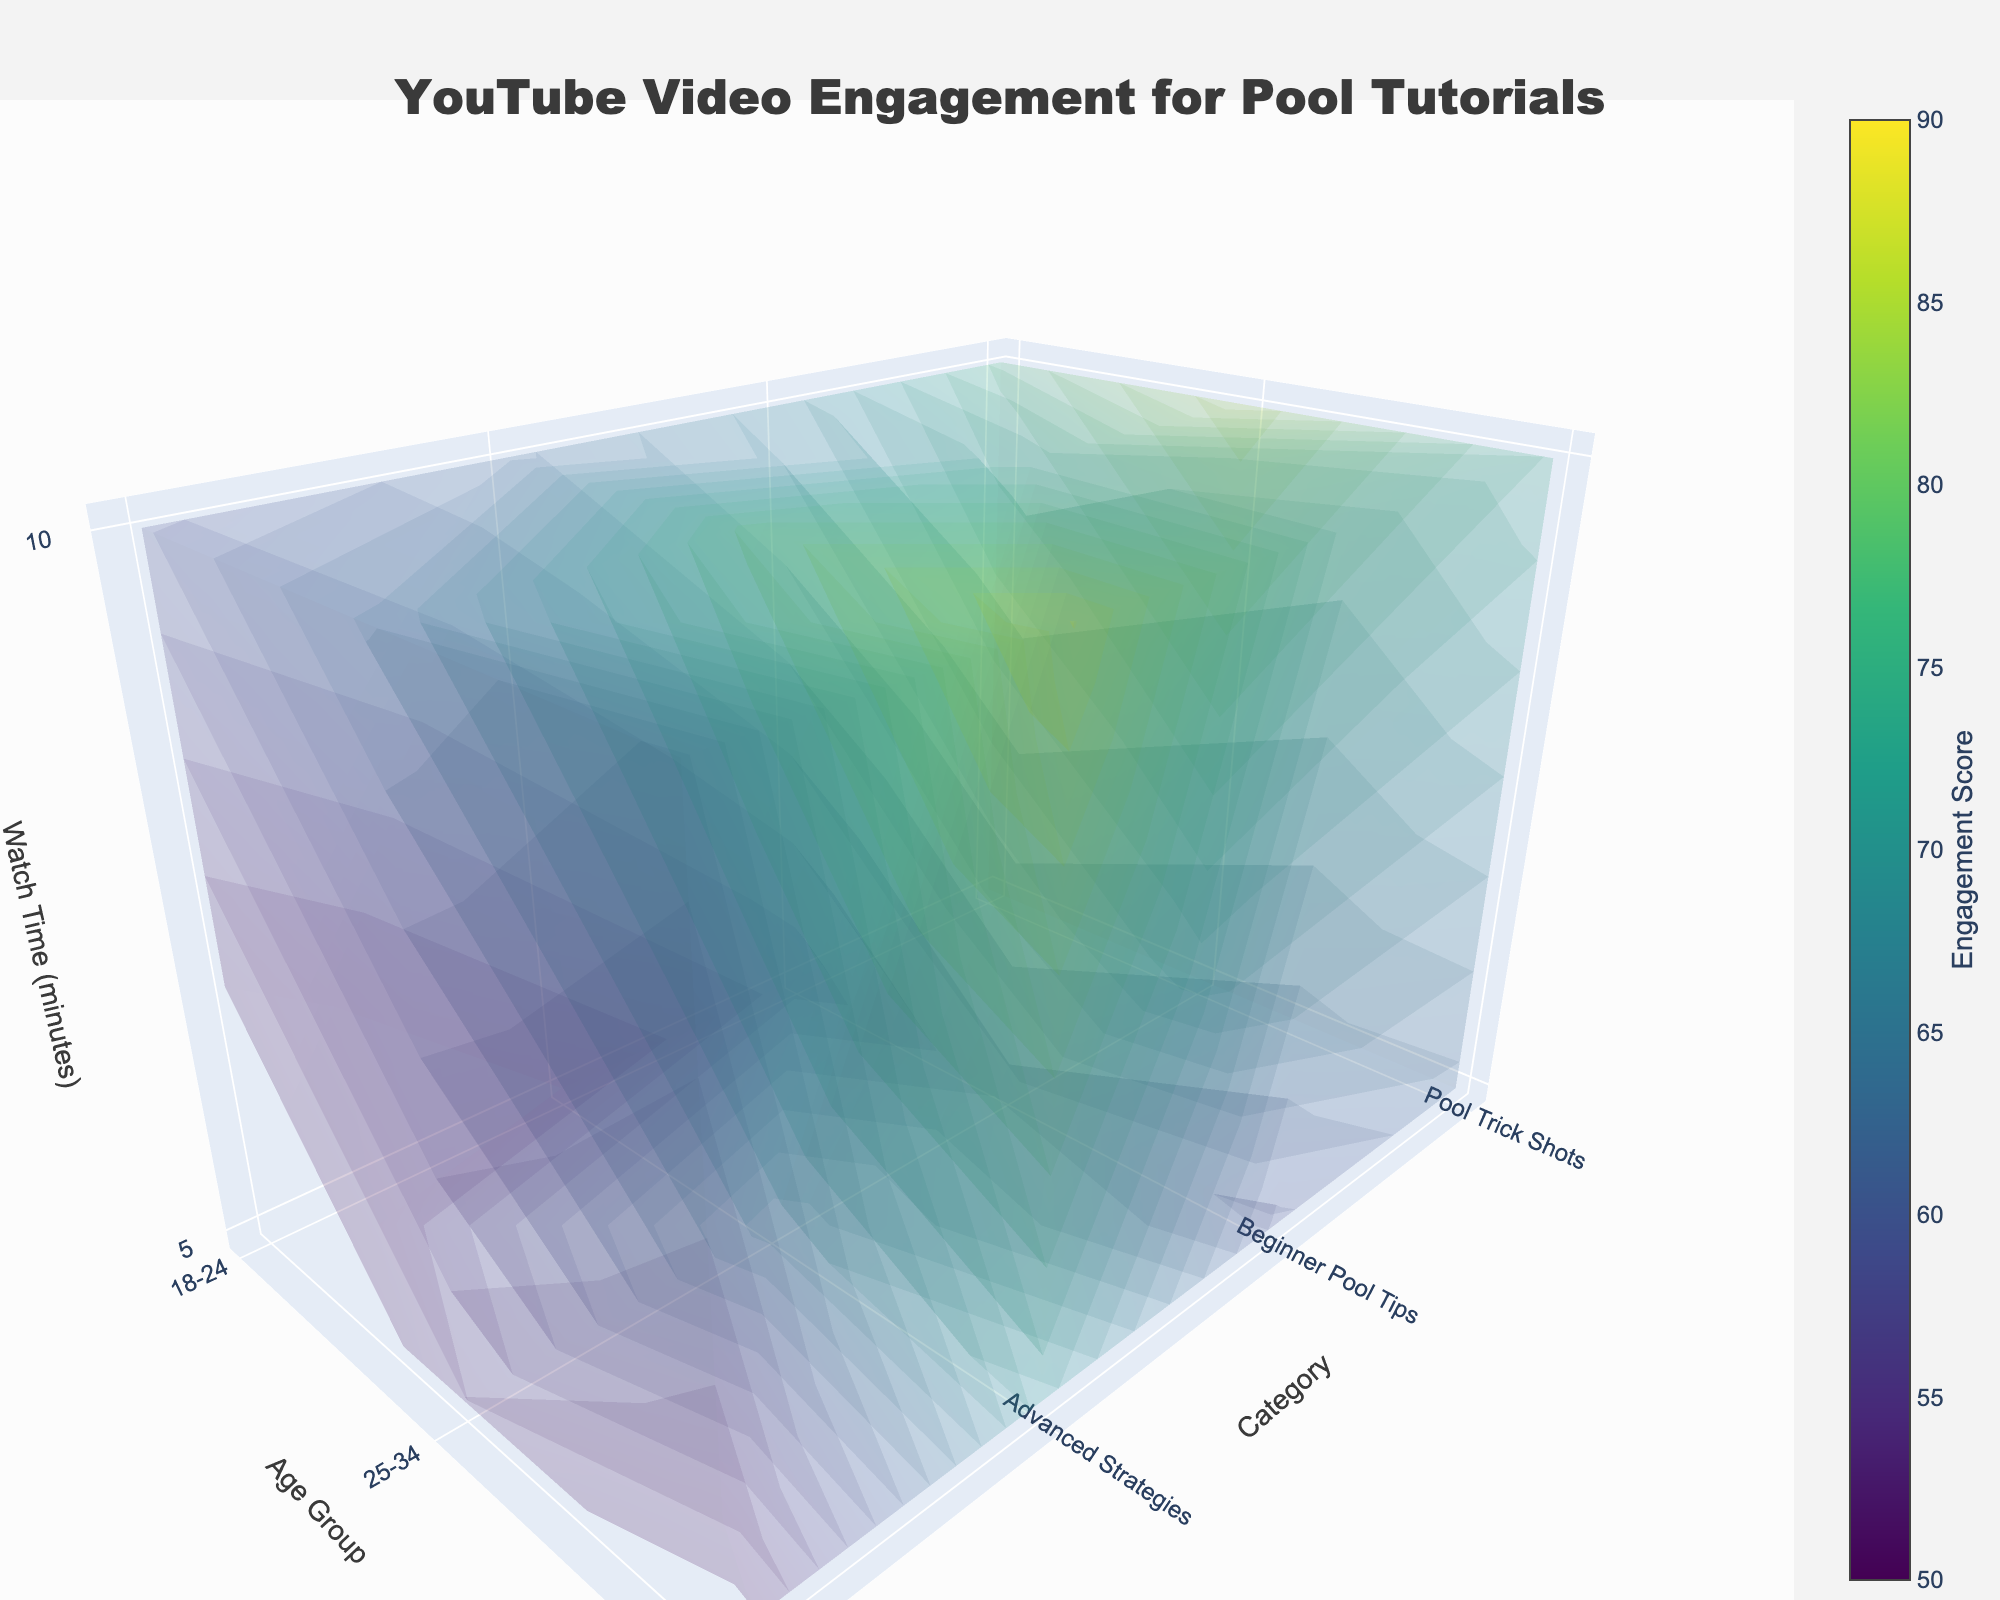What is the title of the plot? The title is typically located at the top of the plot. Here, it reads: "YouTube Video Engagement for Pool Tutorials".
Answer: "YouTube Video Engagement for Pool Tutorials" Which category has the highest engagement score for the 25-34 age group at 10 minutes watch time? To find this, examine the 3D plot for the corresponding age group, watch time, and categories. The highest engagement score for the 25-34 age group at 10 minutes is found under 'Advanced Strategies'.
Answer: Advanced Strategies What is the engagement score for 'Beginner Pool Tips' category in the 35-44 age group and 5 minutes watch time? Locate the grid point corresponding to 'Beginner Pool Tips', age group 35-44, and 5 minutes watch time to find the engagement score of 58.
Answer: 58 Which age group has the highest engagement score overall? By examining all engagement scores across the different age groups, we observe that the age group 35-44 has the highest maximum engagement score of 88.
Answer: 35-44 Between 'Pool Trick Shots' and 'Equipment Reviews', which category has higher engagement in the 18-24 age group at 5 minutes watch time? Compare the engagement scores for 'Pool Trick Shots' and 'Equipment Reviews' for 18-24 age group at 5 minutes watch time to find 'Pool Trick Shots' with 65 against 'Equipment Reviews' with 45.
Answer: Pool Trick Shots What is the average engagement score for 'Advanced Strategies' across all watch times and age groups? Calculate the average by summing the engagement scores for 'Advanced Strategies' across all combinations of watch times (5 and 10 minutes) and age groups (18-24, 25-34, 35-44) then dividing by the number of observations (6). Summing 50, 62, 68, 80, 72, and 88 gives 420; 420/6 = 70.
Answer: 70 What is the difference in engagement scores between 'Pool Trick Shots' in the 25-34 age group at 10 minutes and 'Beginner Pool Tips' in the same group and time? Compare the engagement scores directly: 'Pool Trick Shots' has 85 and 'Beginner Pool Tips' has 72. The difference is 85 - 72 = 13.
Answer: 13 How does engagement vary with watch time within the 'Equipment Reviews' category for the 18-24 age group? Compare the engagement scores for different watch times within 'Equipment Reviews' for the 18-24 age group (45 at 5 minutes and 58 at 10 minutes), showing an increase from 5 to 10 minutes.
Answer: It increases Which metric has more variation across categories, engagement scores for 5 minutes or 10 minutes watch time? Calculate the range of engagement scores (highest minus lowest) across categories for both watch times. For 5 minutes: highest is 72 ('Advanced Strategies'), lowest is 45 ('Equipment Reviews') giving a range of 27. For 10 minutes: highest is 88 ('Advanced Strategies'), lowest is 58 ('Equipment Reviews') giving a range of 30. The 10 minutes watch time has more variation.
Answer: 10 minutes watch time 